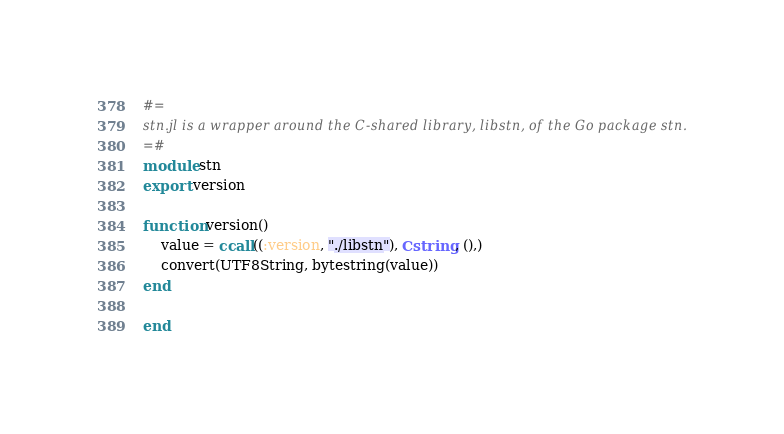<code> <loc_0><loc_0><loc_500><loc_500><_Julia_>#=
stn.jl is a wrapper around the C-shared library, libstn, of the Go package stn.
=#
module stn
export version

function version()
    value = ccall((:version, "./libstn"), Cstring, (),)
    convert(UTF8String, bytestring(value))
end

end
</code> 